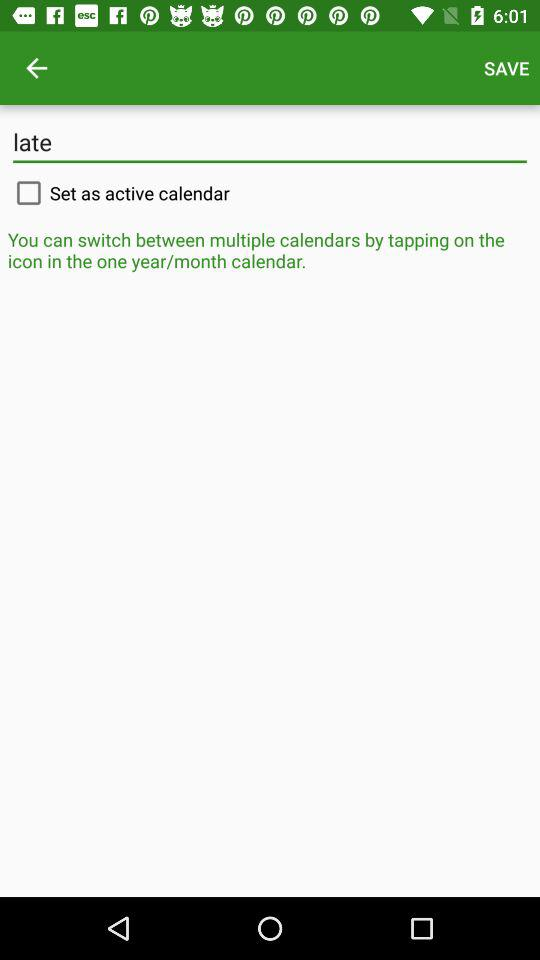What is the status of "Set as active calendar"? The status is "off". 